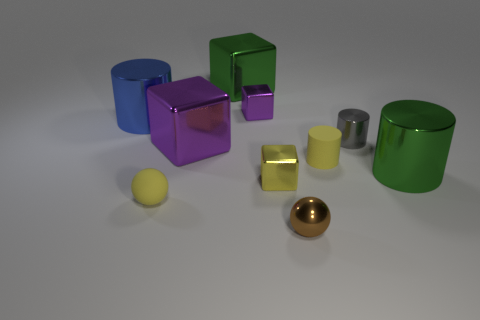Subtract all blue metal cylinders. How many cylinders are left? 3 Subtract 2 blocks. How many blocks are left? 2 Subtract all yellow blocks. How many blocks are left? 3 Subtract all tiny cyan rubber things. Subtract all gray objects. How many objects are left? 9 Add 6 blue cylinders. How many blue cylinders are left? 7 Add 5 tiny brown cubes. How many tiny brown cubes exist? 5 Subtract 1 yellow spheres. How many objects are left? 9 Subtract all blocks. How many objects are left? 6 Subtract all gray spheres. Subtract all green cylinders. How many spheres are left? 2 Subtract all blue spheres. How many green cylinders are left? 1 